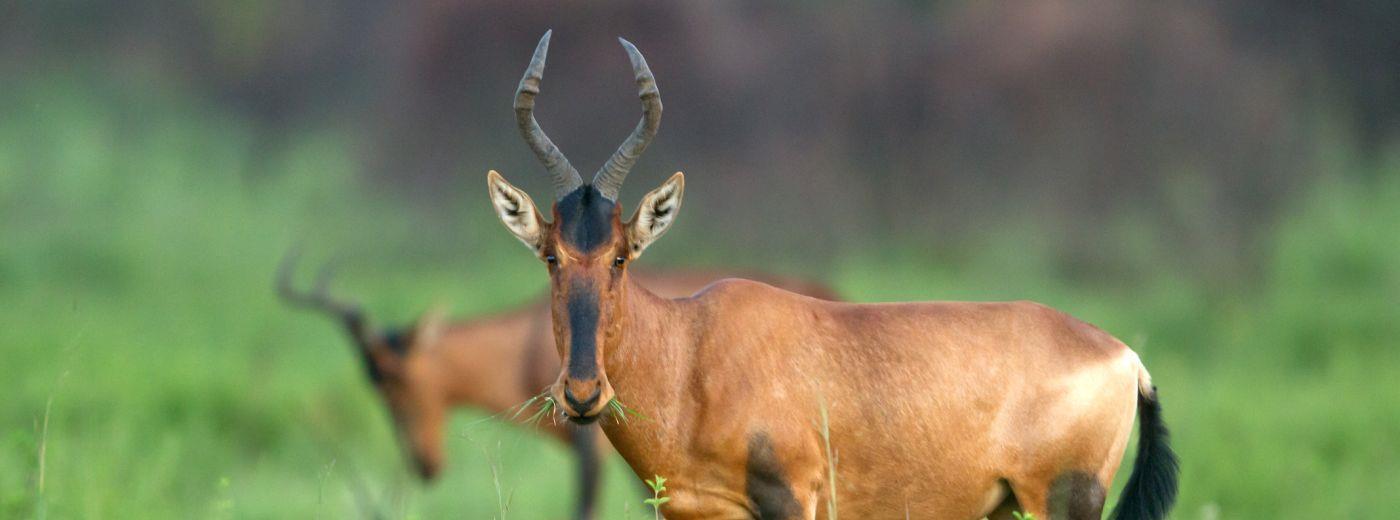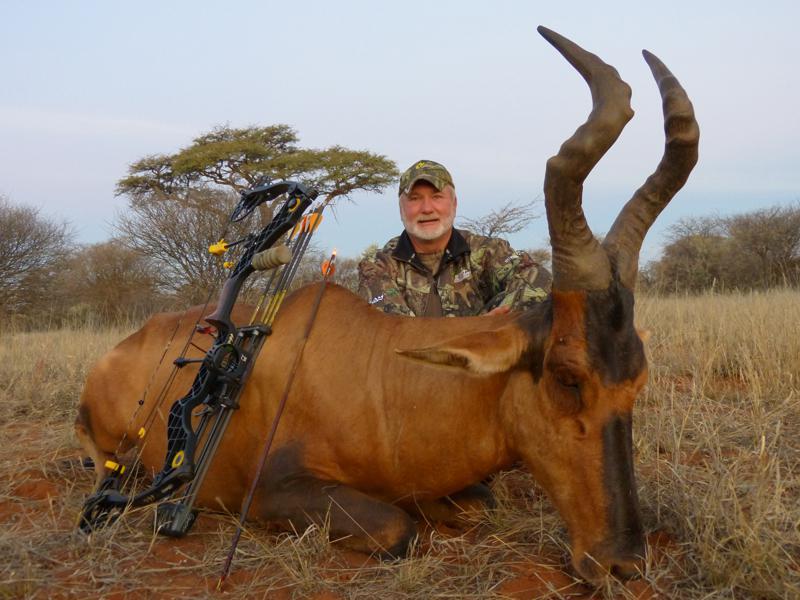The first image is the image on the left, the second image is the image on the right. For the images shown, is this caption "At least one of the images shows a human posing behind a horned animal." true? Answer yes or no. Yes. The first image is the image on the left, the second image is the image on the right. Considering the images on both sides, is "A hunter in camo is posed behind a downed long-horned animal, with his weapon propped against the animal's front." valid? Answer yes or no. Yes. 